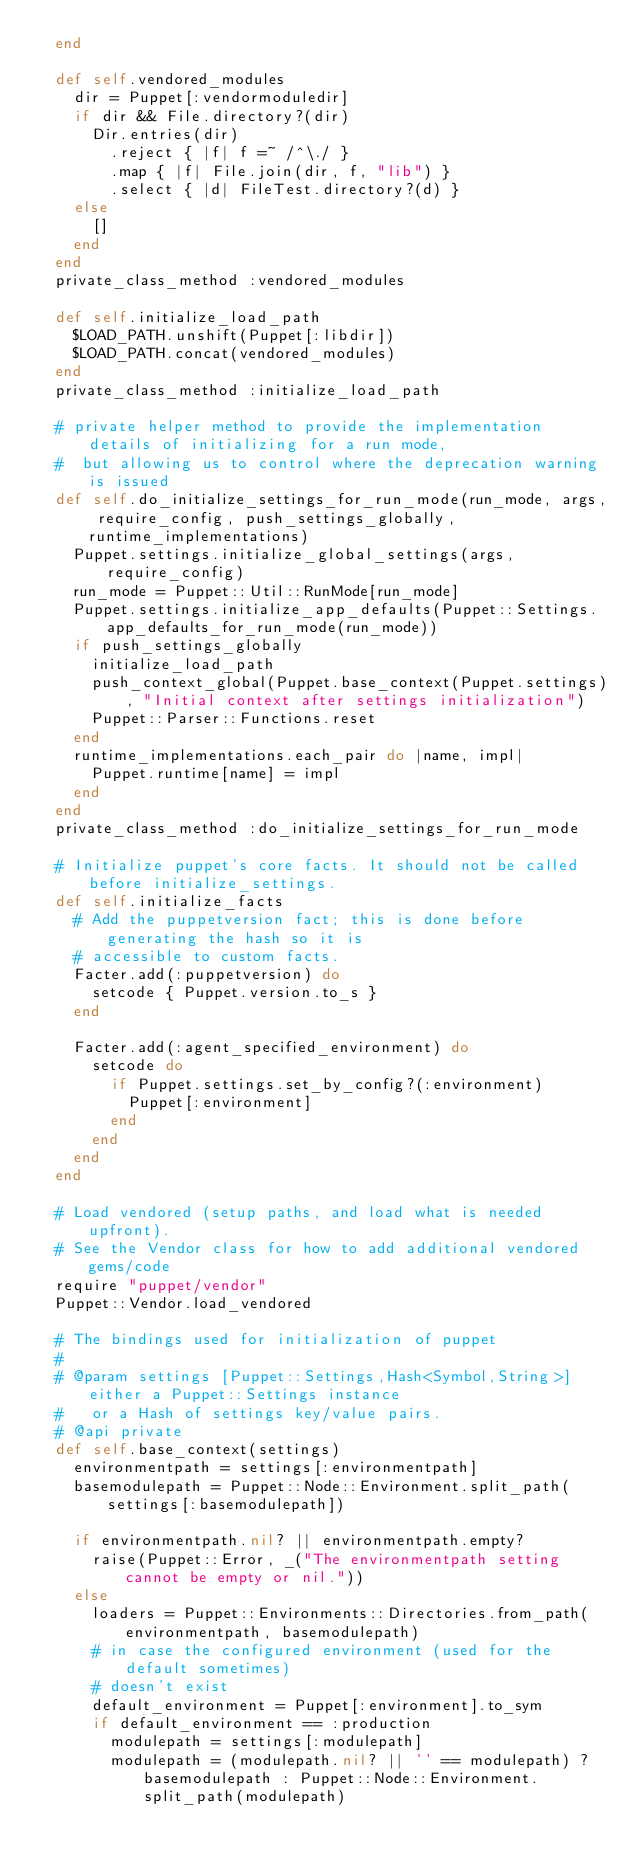<code> <loc_0><loc_0><loc_500><loc_500><_Ruby_>  end

  def self.vendored_modules
    dir = Puppet[:vendormoduledir]
    if dir && File.directory?(dir)
      Dir.entries(dir)
        .reject { |f| f =~ /^\./ }
        .map { |f| File.join(dir, f, "lib") }
        .select { |d| FileTest.directory?(d) }
    else
      []
    end
  end
  private_class_method :vendored_modules

  def self.initialize_load_path
    $LOAD_PATH.unshift(Puppet[:libdir])
    $LOAD_PATH.concat(vendored_modules)
  end
  private_class_method :initialize_load_path

  # private helper method to provide the implementation details of initializing for a run mode,
  #  but allowing us to control where the deprecation warning is issued
  def self.do_initialize_settings_for_run_mode(run_mode, args, require_config, push_settings_globally, runtime_implementations)
    Puppet.settings.initialize_global_settings(args, require_config)
    run_mode = Puppet::Util::RunMode[run_mode]
    Puppet.settings.initialize_app_defaults(Puppet::Settings.app_defaults_for_run_mode(run_mode))
    if push_settings_globally
      initialize_load_path
      push_context_global(Puppet.base_context(Puppet.settings), "Initial context after settings initialization")
      Puppet::Parser::Functions.reset
    end
    runtime_implementations.each_pair do |name, impl|
      Puppet.runtime[name] = impl
    end
  end
  private_class_method :do_initialize_settings_for_run_mode

  # Initialize puppet's core facts. It should not be called before initialize_settings.
  def self.initialize_facts
    # Add the puppetversion fact; this is done before generating the hash so it is
    # accessible to custom facts.
    Facter.add(:puppetversion) do
      setcode { Puppet.version.to_s }
    end

    Facter.add(:agent_specified_environment) do
      setcode do
        if Puppet.settings.set_by_config?(:environment)
          Puppet[:environment]
        end
      end
    end
  end

  # Load vendored (setup paths, and load what is needed upfront).
  # See the Vendor class for how to add additional vendored gems/code
  require "puppet/vendor"
  Puppet::Vendor.load_vendored

  # The bindings used for initialization of puppet
  #
  # @param settings [Puppet::Settings,Hash<Symbol,String>] either a Puppet::Settings instance
  #   or a Hash of settings key/value pairs.
  # @api private
  def self.base_context(settings)
    environmentpath = settings[:environmentpath]
    basemodulepath = Puppet::Node::Environment.split_path(settings[:basemodulepath])

    if environmentpath.nil? || environmentpath.empty?
      raise(Puppet::Error, _("The environmentpath setting cannot be empty or nil."))
    else
      loaders = Puppet::Environments::Directories.from_path(environmentpath, basemodulepath)
      # in case the configured environment (used for the default sometimes)
      # doesn't exist
      default_environment = Puppet[:environment].to_sym
      if default_environment == :production
        modulepath = settings[:modulepath]
        modulepath = (modulepath.nil? || '' == modulepath) ? basemodulepath : Puppet::Node::Environment.split_path(modulepath)</code> 